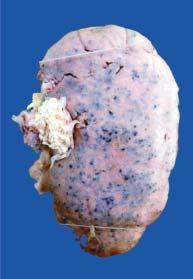does the peripheral zone show characteristic 'flea bitten kidney ' due to tiny petechial haemorrhages on the surface?
Answer the question using a single word or phrase. No 